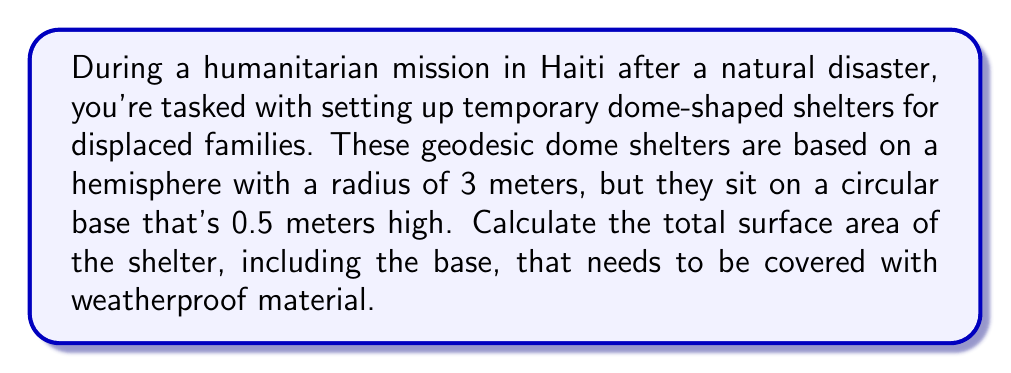Help me with this question. Let's approach this step-by-step:

1) The shelter consists of two parts: the hemispherical dome and the cylindrical base.

2) For the hemispherical dome:
   The surface area of a hemisphere is given by the formula:
   $$A_{hemisphere} = 2\pi r^2$$
   Where $r$ is the radius.
   $$A_{hemisphere} = 2\pi (3\text{ m})^2 = 18\pi \text{ m}^2$$

3) For the cylindrical base:
   We need to calculate the lateral surface area of the cylinder (the curved part).
   The formula for the lateral surface area of a cylinder is:
   $$A_{cylinder} = 2\pi rh$$
   Where $r$ is the radius of the base and $h$ is the height.
   $$A_{cylinder} = 2\pi (3\text{ m})(0.5\text{ m}) = 3\pi \text{ m}^2$$

4) We also need to include the circular base of the shelter:
   The area of a circle is given by:
   $$A_{circle} = \pi r^2$$
   $$A_{circle} = \pi (3\text{ m})^2 = 9\pi \text{ m}^2$$

5) The total surface area is the sum of these three parts:
   $$A_{total} = A_{hemisphere} + A_{cylinder} + A_{circle}$$
   $$A_{total} = 18\pi \text{ m}^2 + 3\pi \text{ m}^2 + 9\pi \text{ m}^2 = 30\pi \text{ m}^2$$

6) To get the final answer in square meters:
   $$A_{total} = 30\pi \text{ m}^2 \approx 94.25 \text{ m}^2$$
Answer: The total surface area of the shelter is $30\pi \text{ m}^2$ or approximately 94.25 m². 